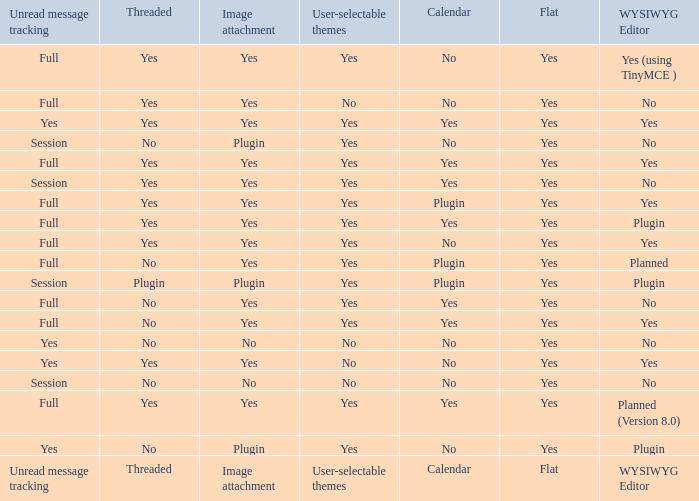Which Calendar has a User-selectable themes of user-selectable themes? Calendar. 